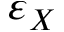<formula> <loc_0><loc_0><loc_500><loc_500>\varepsilon _ { X }</formula> 